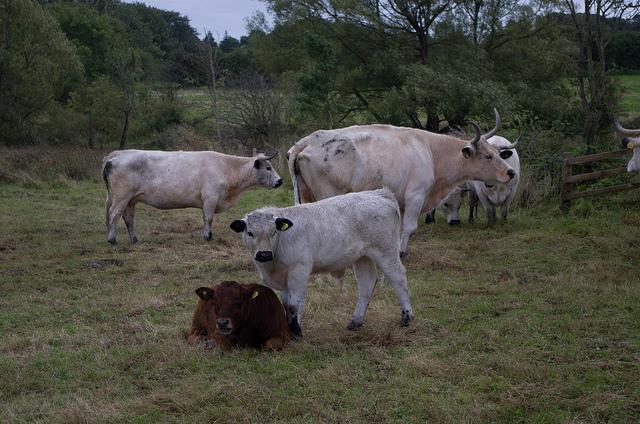How many of the cattle have horns?
Give a very brief answer. 4. How many animals are in this picture?
Give a very brief answer. 7. How many cows are in the picture?
Give a very brief answer. 5. 